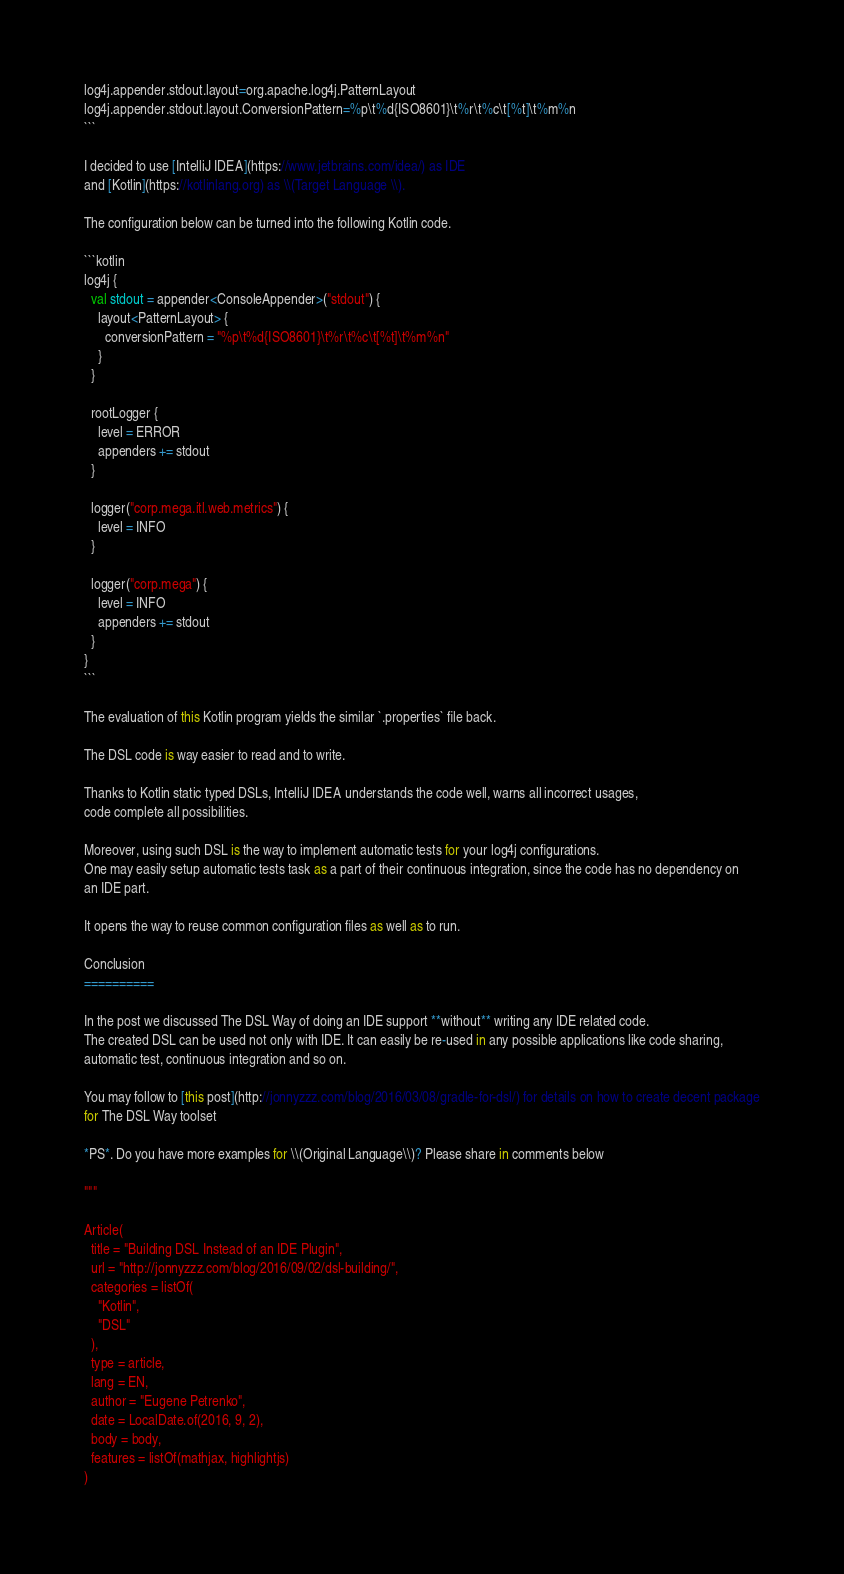Convert code to text. <code><loc_0><loc_0><loc_500><loc_500><_Kotlin_>log4j.appender.stdout.layout=org.apache.log4j.PatternLayout
log4j.appender.stdout.layout.ConversionPattern=%p\t%d{ISO8601}\t%r\t%c\t[%t]\t%m%n
```

I decided to use [IntelliJ IDEA](https://www.jetbrains.com/idea/) as IDE 
and [Kotlin](https://kotlinlang.org) as \\(Target Language \\).
 
The configuration below can be turned into the following Kotlin code.

```kotlin
log4j {
  val stdout = appender<ConsoleAppender>("stdout") {
    layout<PatternLayout> {
      conversionPattern = "%p\t%d{ISO8601}\t%r\t%c\t[%t]\t%m%n"
    }
  }

  rootLogger {
    level = ERROR
    appenders += stdout
  }

  logger("corp.mega.itl.web.metrics") {
    level = INFO
  }

  logger("corp.mega") {
    level = INFO
    appenders += stdout
  }
}
```

The evaluation of this Kotlin program yields the similar `.properties` file back. 

The DSL code is way easier to read and to write.

Thanks to Kotlin static typed DSLs, IntelliJ IDEA understands the code well, warns all incorrect usages,
code complete all possibilities. 

Moreover, using such DSL is the way to implement automatic tests for your log4j configurations.
One may easily setup automatic tests task as a part of their continuous integration, since the code has no dependency on 
an IDE part. 
 
It opens the way to reuse common configuration files as well as to run. 

Conclusion
==========

In the post we discussed The DSL Way of doing an IDE support **without** writing any IDE related code. 
The created DSL can be used not only with IDE. It can easily be re-used in any possible applications like code sharing,
automatic test, continuous integration and so on.

You may follow to [this post](http://jonnyzzz.com/blog/2016/03/08/gradle-for-dsl/) for details on how to create decent package
for The DSL Way toolset

*PS*. Do you have more examples for \\(Original Language\\)? Please share in comments below

"""

Article(
  title = "Building DSL Instead of an IDE Plugin",
  url = "http://jonnyzzz.com/blog/2016/09/02/dsl-building/",
  categories = listOf(
    "Kotlin",
    "DSL"
  ),
  type = article,
  lang = EN,
  author = "Eugene Petrenko",
  date = LocalDate.of(2016, 9, 2),
  body = body,
  features = listOf(mathjax, highlightjs)
)
</code> 